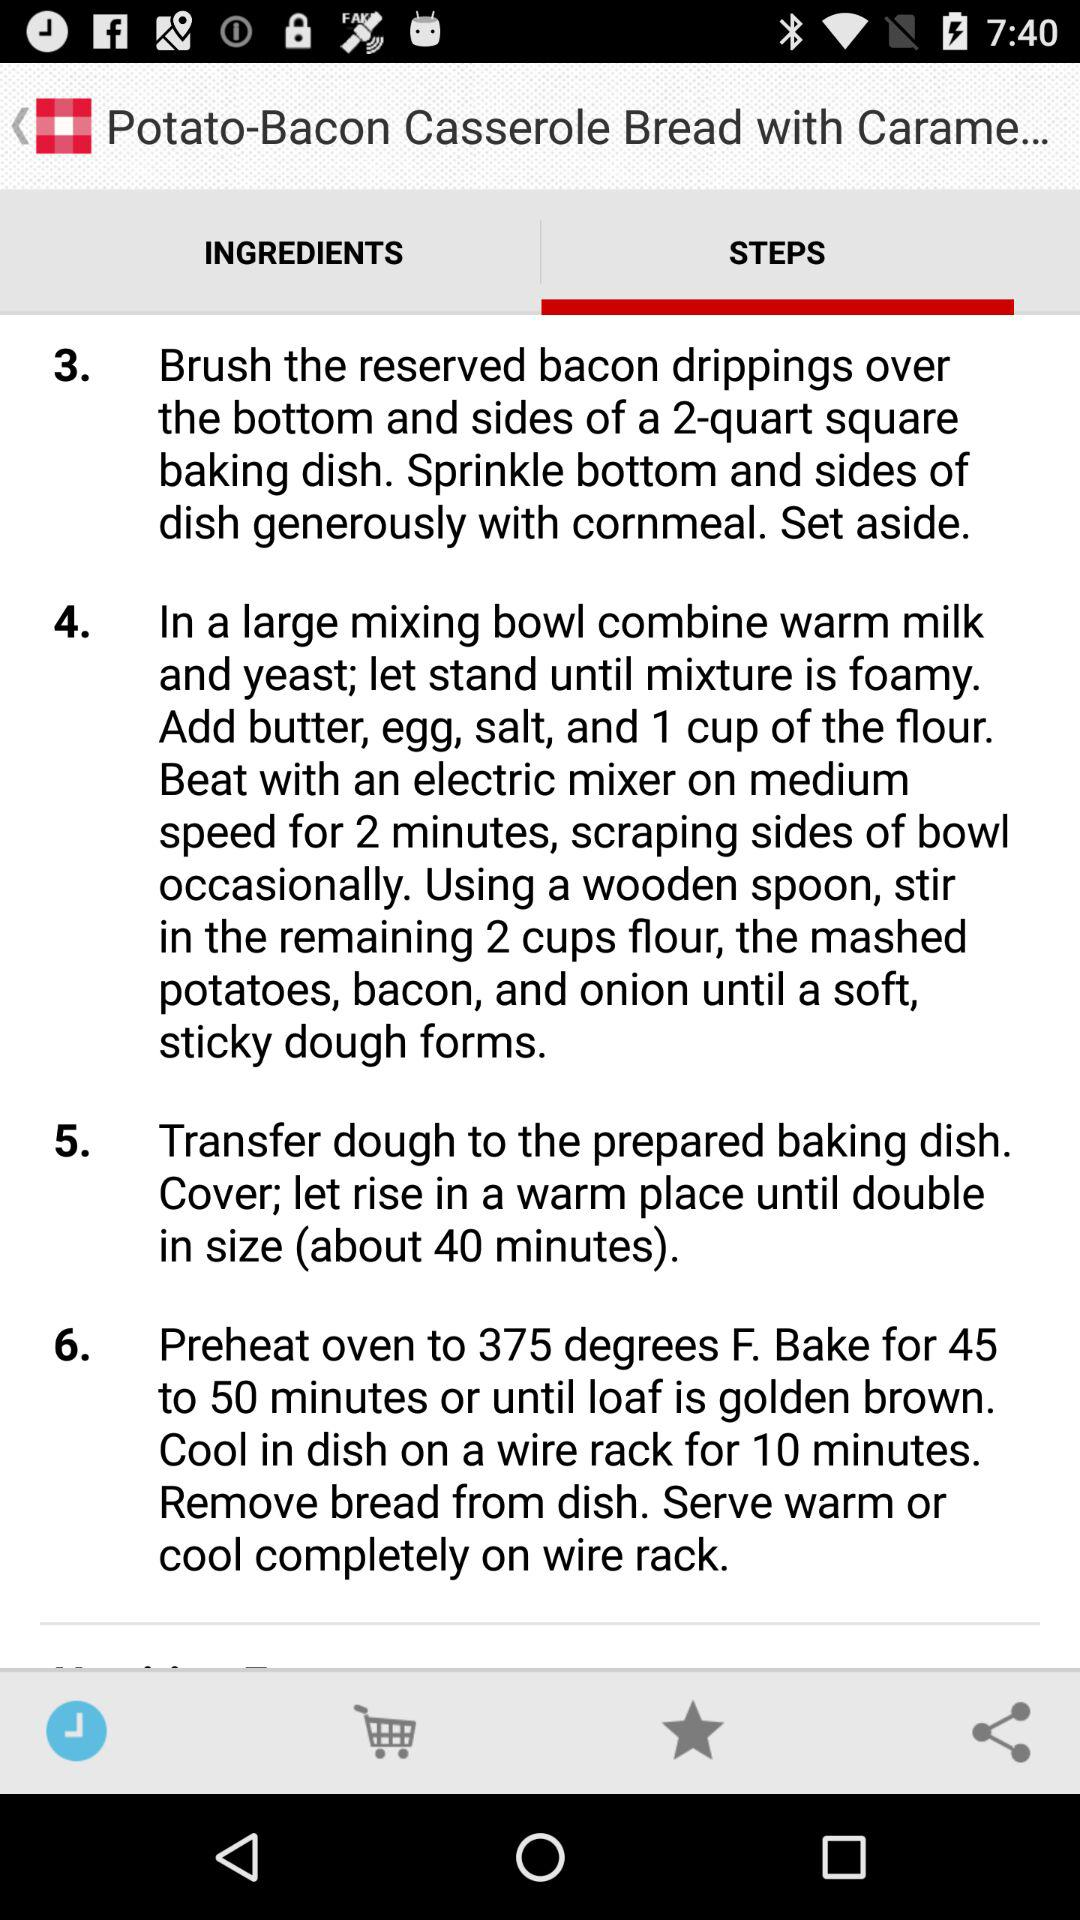To what degree should the oven be preheated? The oven should be preheated to 375 degrees F. 